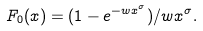<formula> <loc_0><loc_0><loc_500><loc_500>F _ { 0 } ( x ) = ( 1 - e ^ { - w x ^ { \sigma } } ) / w x ^ { \sigma } .</formula> 